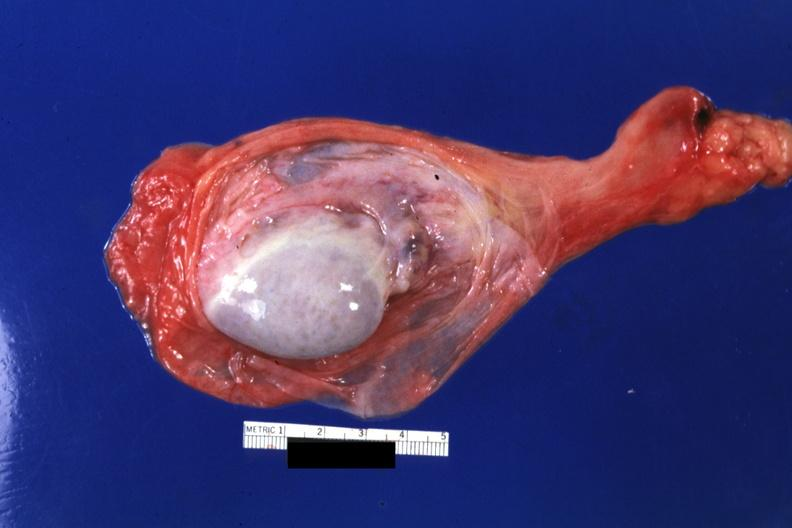what is present?
Answer the question using a single word or phrase. Testicle 